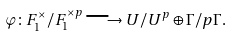<formula> <loc_0><loc_0><loc_500><loc_500>\varphi \colon F _ { 1 } ^ { \times } / F _ { 1 } ^ { \times p } \longrightarrow U / U ^ { p } \oplus \Gamma / p \Gamma .</formula> 